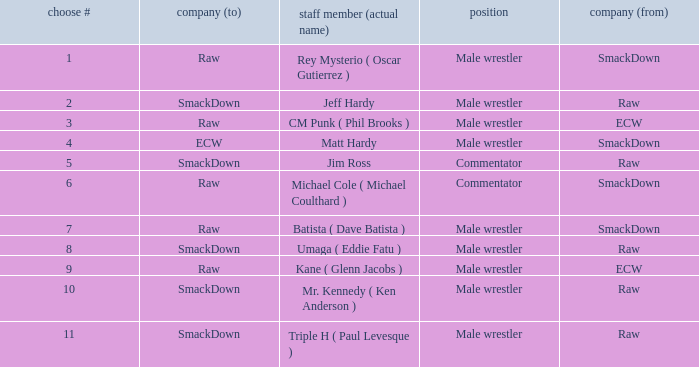What is the real name of the Pick # that is greater than 9? Mr. Kennedy ( Ken Anderson ), Triple H ( Paul Levesque ). 